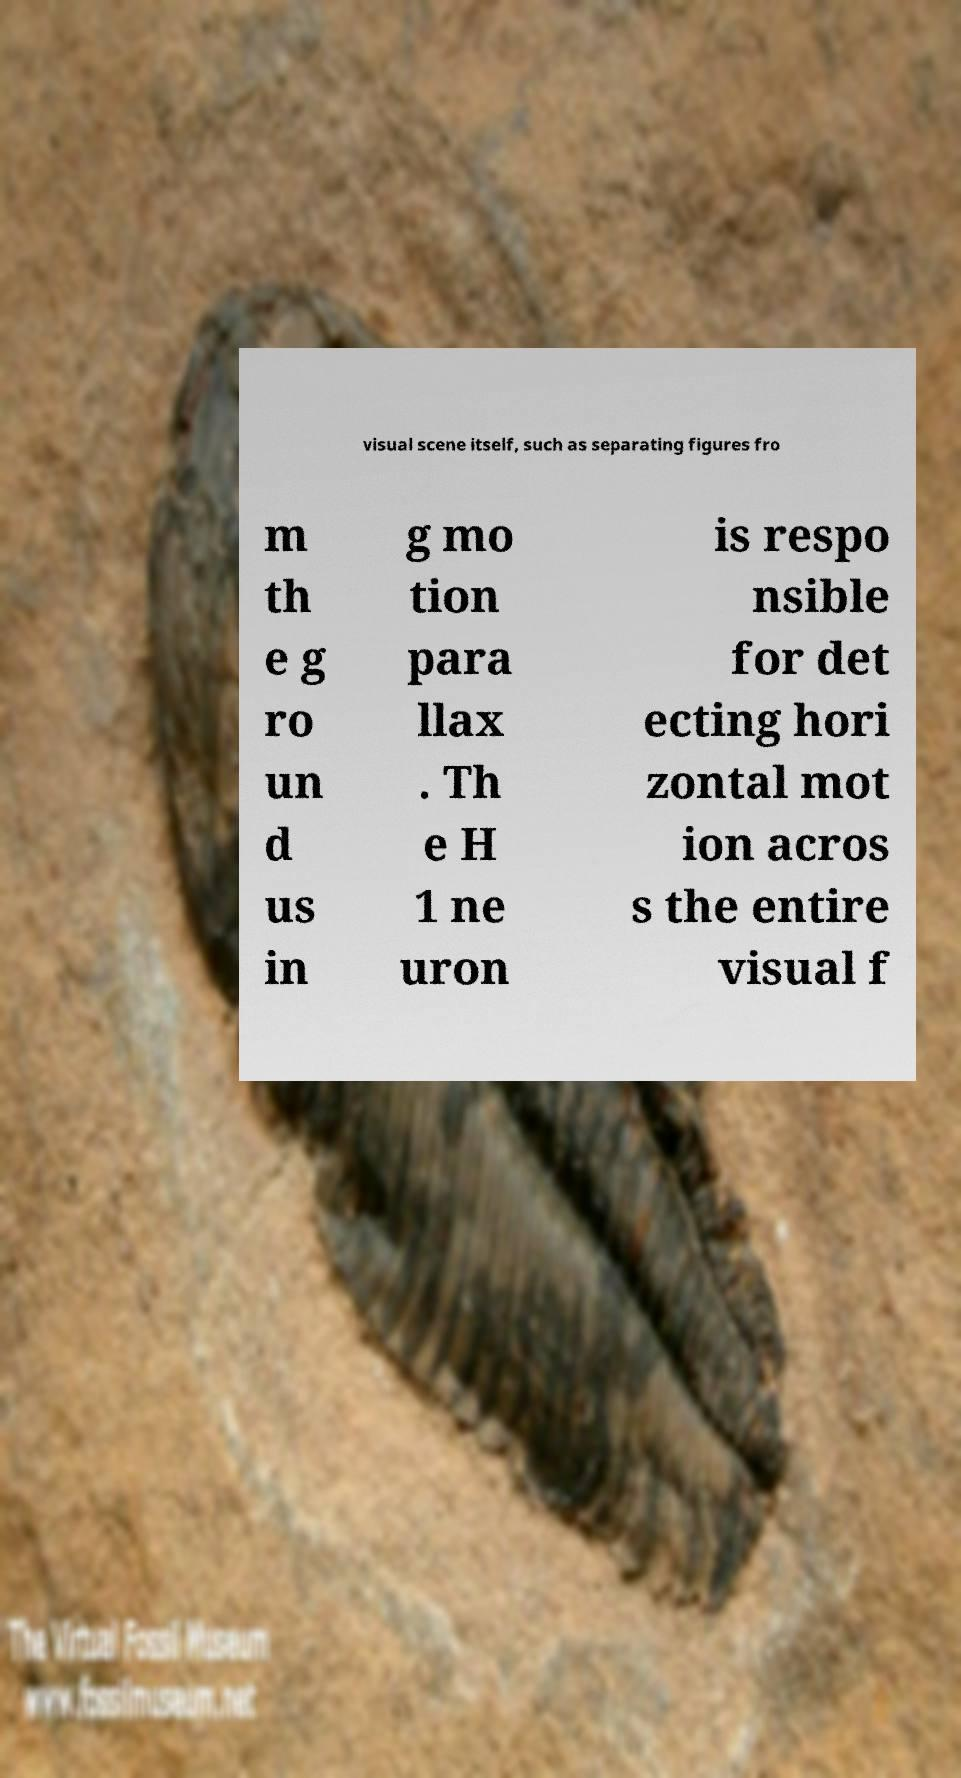Can you accurately transcribe the text from the provided image for me? visual scene itself, such as separating figures fro m th e g ro un d us in g mo tion para llax . Th e H 1 ne uron is respo nsible for det ecting hori zontal mot ion acros s the entire visual f 